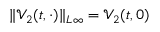Convert formula to latex. <formula><loc_0><loc_0><loc_500><loc_500>\| \mathcal { V } _ { 2 } ( t , \cdot ) \| _ { L \infty } = \mathcal { V } _ { 2 } ( t , 0 )</formula> 